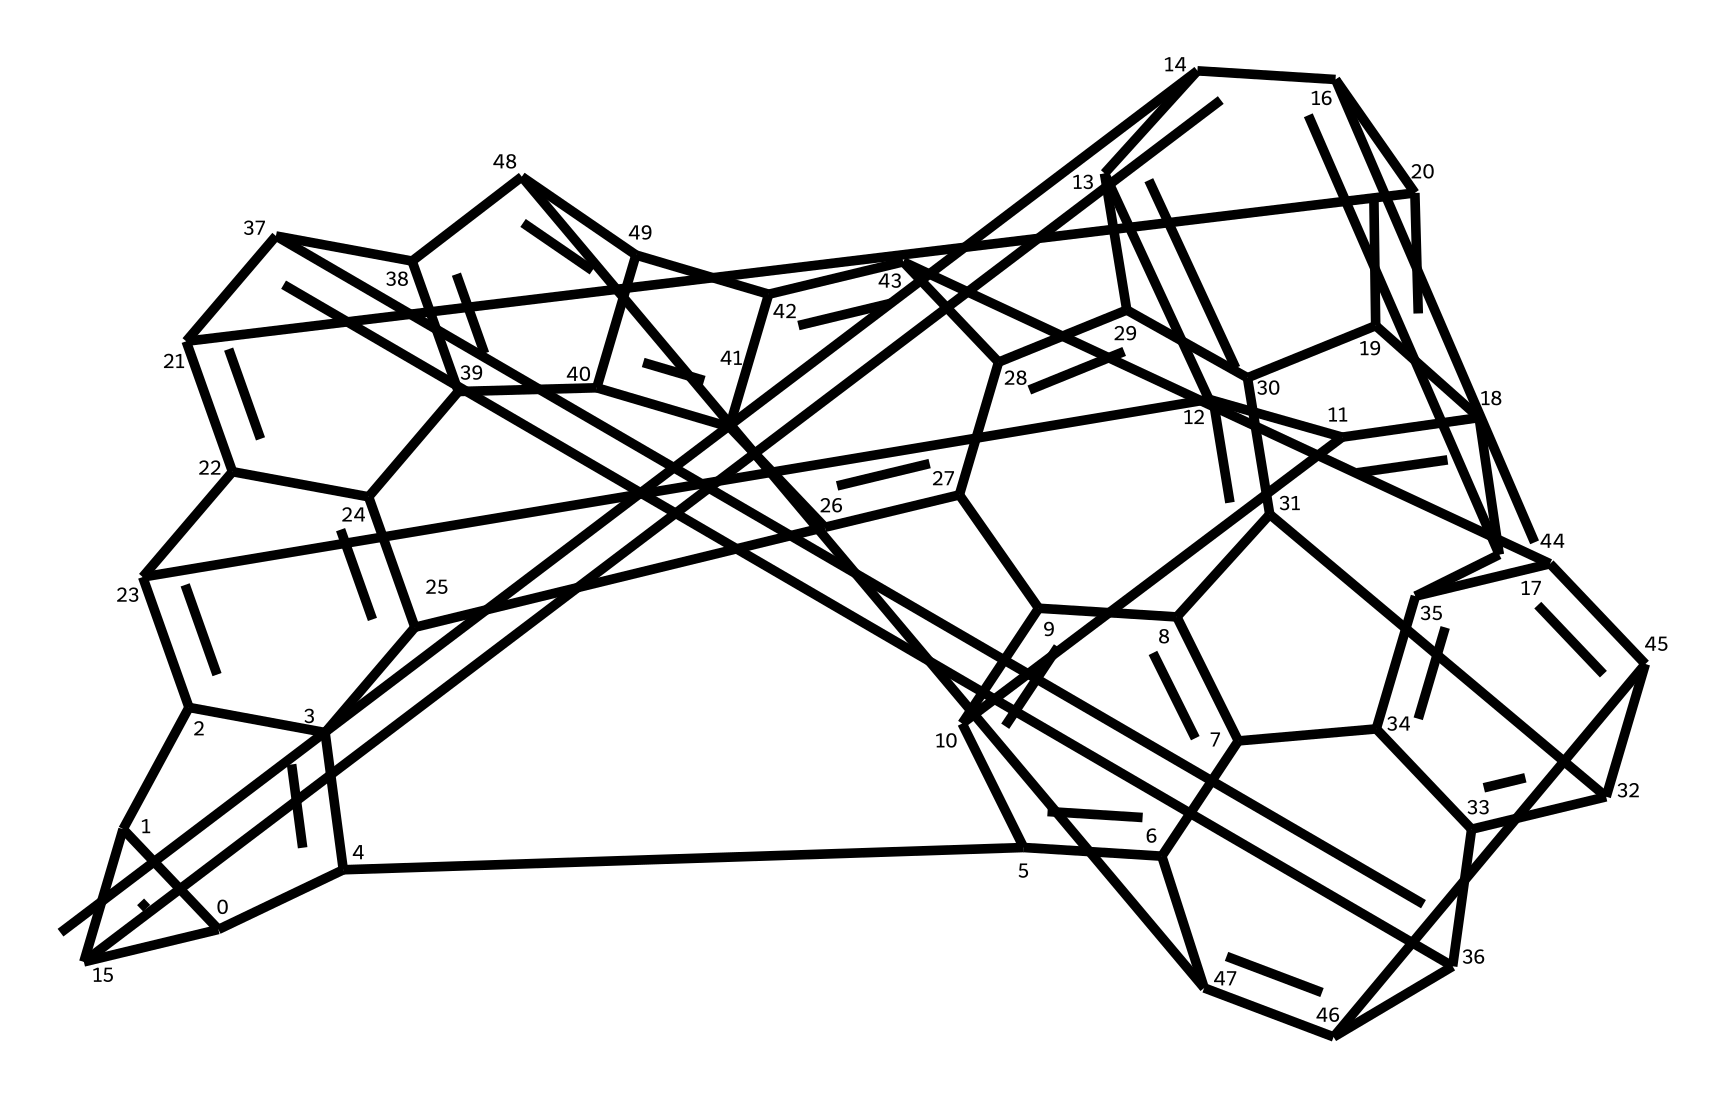What is the molecular formula of C60? The molecular formula represents the number of each type of atom in the molecule. In the case of C60 (Buckminsterfullerene), there are 60 carbon atoms and no other elements present, thus the molecular formula is C60.
Answer: C60 How many atoms are present in C60? The total number of atoms in a molecule is determined by the number of carbon atoms present. For C60, there are 60 carbon atoms, and since no other elements are involved, the total count of atoms is 60.
Answer: 60 What type of structure does C60 have? C60 has a specific structural arrangement known as a truncated icosahedron, which consists of 20 hexagonal and 12 pentagonal faces. The arrangement of these faces contributes to its stability and spherical shape.
Answer: truncated icosahedron What is the hybridization of the carbon atoms in C60? In C60, each carbon atom is involved in forming bonds with three other carbon atoms, leading to a trigonal planar arrangement around each carbon atom. This bonding results in an sp2 hybridization for each carbon atom.
Answer: sp2 How many pentagonal and hexagonal faces does C60 have? The structure of C60 contains 12 pentagonal faces and 20 hexagonal faces, which are characteristic features that define its overall geometry and stability.
Answer: 12 pentagonal and 20 hexagonal What unique property does C60 exhibit due to its structure? The spherical structure of C60 allows it to exhibit unique properties such as high stability, resilience, and the ability to act as an electron acceptor. This characteristic is a result of the arrangement of the carbon atoms and their bonding interactions.
Answer: high stability Is C60 a conductor or insulator? Due to the structure and bonding, C60 exhibits semiconducting behavior, which means it can behave as both a conductor and an insulator under different conditions. This property is linked to its electronic structure arising from the arrangement of carbon atoms.
Answer: semiconducting 